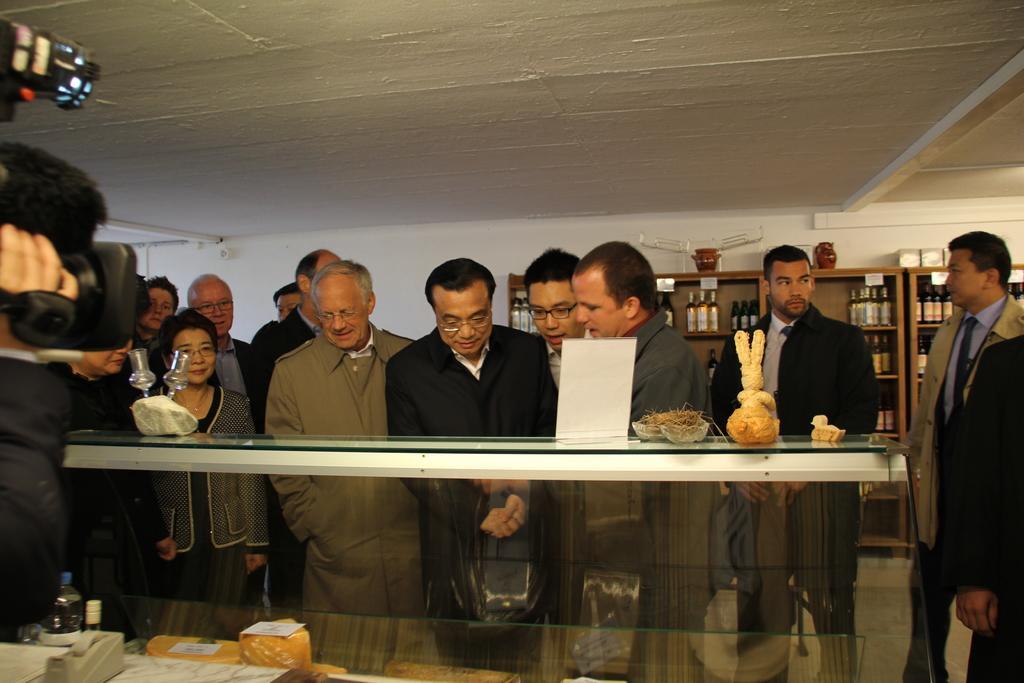In one or two sentences, can you explain what this image depicts? In the image we can see there are people around, standing, wearing clothes and some of them are wearing spectacles. Here we can see a glass shelf, in it we can see food items. Here we can see a video camera, glass, floor, shelves and bottles on the shelf and a roof. 